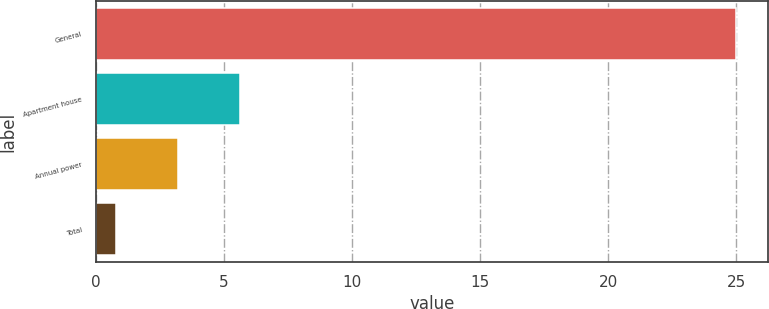Convert chart to OTSL. <chart><loc_0><loc_0><loc_500><loc_500><bar_chart><fcel>General<fcel>Apartment house<fcel>Annual power<fcel>Total<nl><fcel>25<fcel>5.64<fcel>3.22<fcel>0.8<nl></chart> 